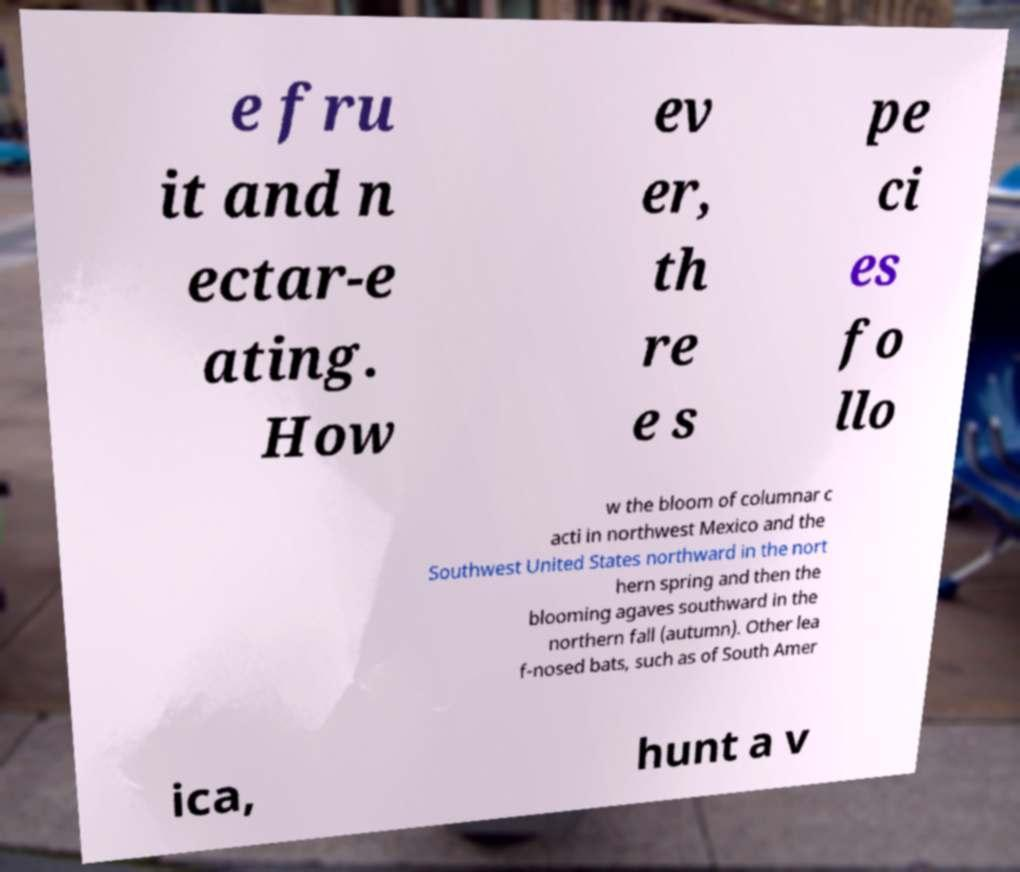Can you read and provide the text displayed in the image?This photo seems to have some interesting text. Can you extract and type it out for me? e fru it and n ectar-e ating. How ev er, th re e s pe ci es fo llo w the bloom of columnar c acti in northwest Mexico and the Southwest United States northward in the nort hern spring and then the blooming agaves southward in the northern fall (autumn). Other lea f-nosed bats, such as of South Amer ica, hunt a v 